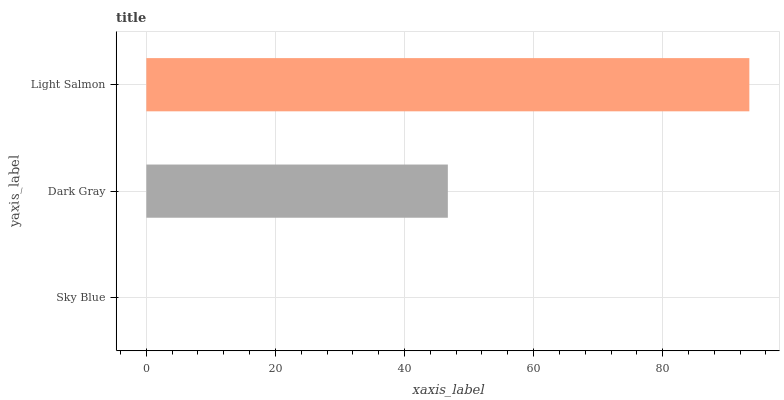Is Sky Blue the minimum?
Answer yes or no. Yes. Is Light Salmon the maximum?
Answer yes or no. Yes. Is Dark Gray the minimum?
Answer yes or no. No. Is Dark Gray the maximum?
Answer yes or no. No. Is Dark Gray greater than Sky Blue?
Answer yes or no. Yes. Is Sky Blue less than Dark Gray?
Answer yes or no. Yes. Is Sky Blue greater than Dark Gray?
Answer yes or no. No. Is Dark Gray less than Sky Blue?
Answer yes or no. No. Is Dark Gray the high median?
Answer yes or no. Yes. Is Dark Gray the low median?
Answer yes or no. Yes. Is Light Salmon the high median?
Answer yes or no. No. Is Sky Blue the low median?
Answer yes or no. No. 